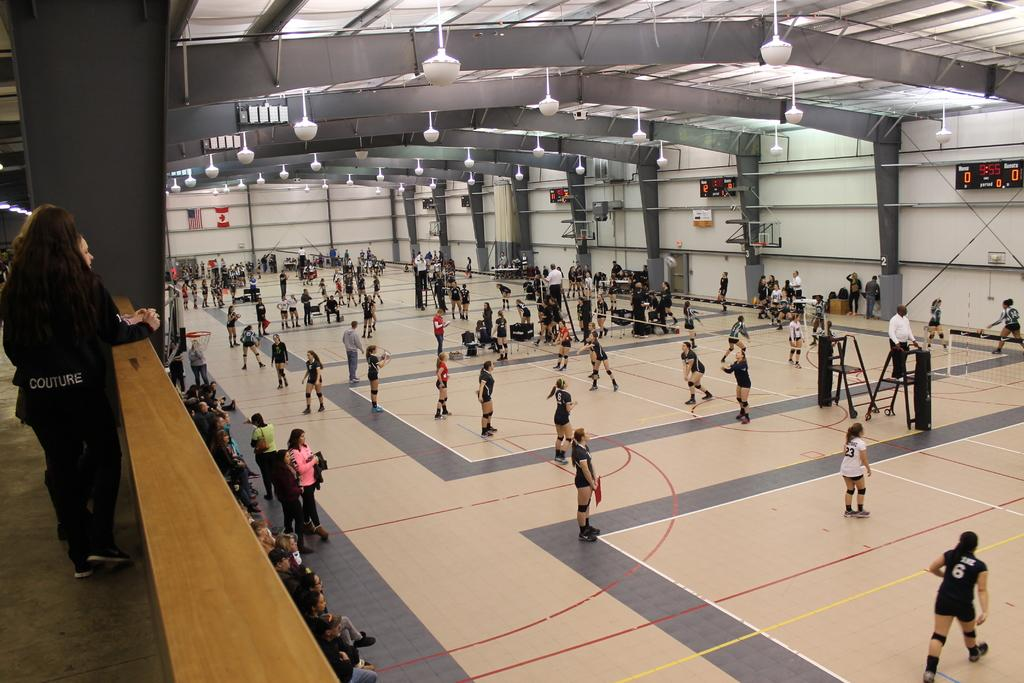What is happening with the group of people in the image? The group of people is on the ground in the image. What can be seen in the background of the image? There is a wall in the image. What is providing illumination in the image? There are lights in the image. What is present to indicate a specific event or team? There are flags in the image. What might be used to display scores or results? There are scoreboards in the image. Can you describe any other objects in the image? There are some objects in the image, but their specific nature is not mentioned in the provided facts. What type of alley is visible in the image? There is no alley present in the image. What kind of quilt is being used by the group of people in the image? There is no quilt present in the image. 